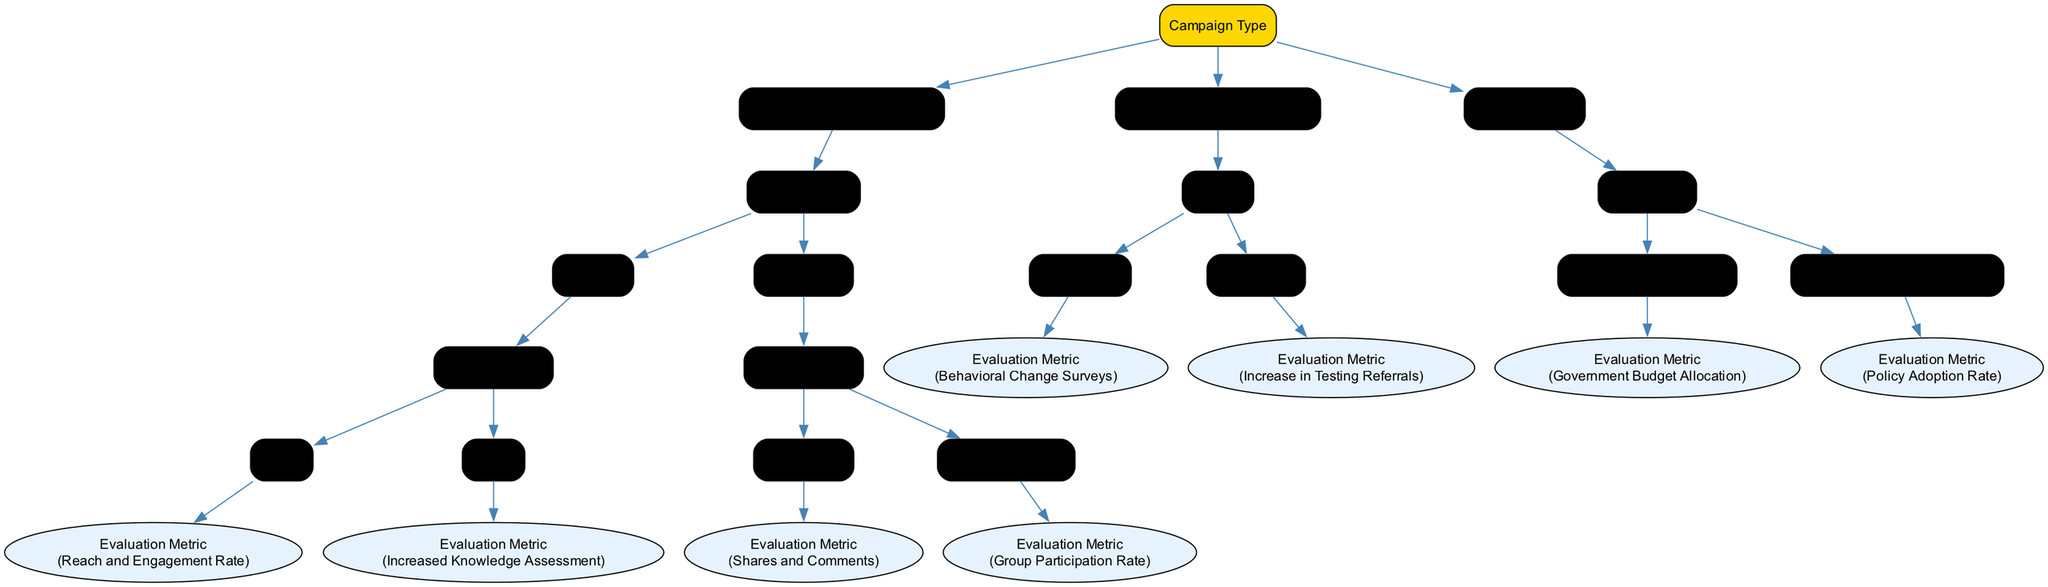What are the three main types of advocacy campaigns? The root node of the diagram lists three main campaign types: Public Service Announcement, Community Outreach Program, and Policy Advocacy.
Answer: Public Service Announcement, Community Outreach Program, Policy Advocacy Which media channel is linked to the evaluation metric for youth? The node "Television" under "Public Service Announcement" connects to the target audience "Youth," which specifies "Reach and Engagement Rate" as the evaluation metric.
Answer: Reach and Engagement Rate What evaluation metric is associated with location in Community Outreach Program? The "Location" node under "Community Outreach Program" branches out to "High Schools" and "Local Clinics," and both lead to specific evaluation metrics, which are "Behavioral Change Surveys" for high schools and "Increase in Testing Referrals" for local clinics.
Answer: Behavioral Change Surveys, Increase in Testing Referrals How many target audiences does the Social Media channel have? The "Social Media" node under "Public Service Announcement" branches into two target audiences: "Young Adults" and "Community Groups," resulting in a total of two distinct audiences.
Answer: 2 Which evaluation metric corresponds to the policy "HIV/AIDS Education in Schools"? Under "Policy Advocacy," the target policy "HIV/AIDS Education in Schools" points to the evaluation metric "Policy Adoption Rate."
Answer: Policy Adoption Rate Which campaign type evaluates the Government Budget Allocation? The node for "Funding for HIV Programs" is specific to "Policy Advocacy," which designates "Government Budget Allocation" as the evaluation metric.
Answer: Policy Advocacy What is the evaluation metric for Adults in the Television media channel? Under the "Television" media channel within the "Public Service Announcement" category, the target audience "Adults" leads to the evaluation metric "Increased Knowledge Assessment."
Answer: Increased Knowledge Assessment What is the target audience for the evaluation metric "Shares and Comments"? The metric "Shares and Comments" is linked to the target audience "Young Adults" within the "Social Media" media channel in the "Public Service Announcement" category.
Answer: Young Adults 